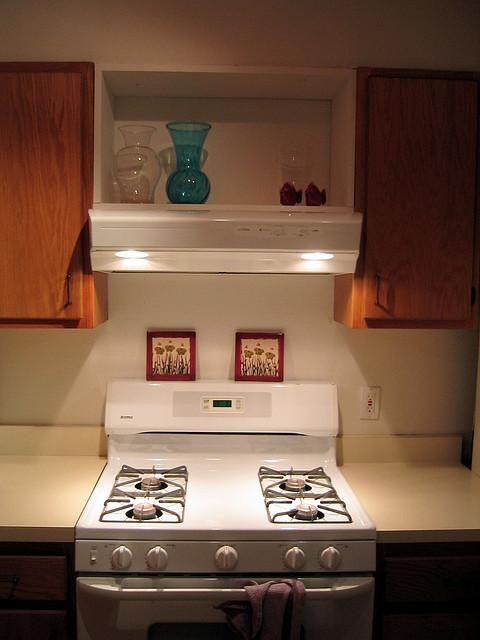What does the middle knob on the stove turn on? Please explain your reasoning. oven. Typically the right two turn on the right burners and the left two turn on the left burners. 